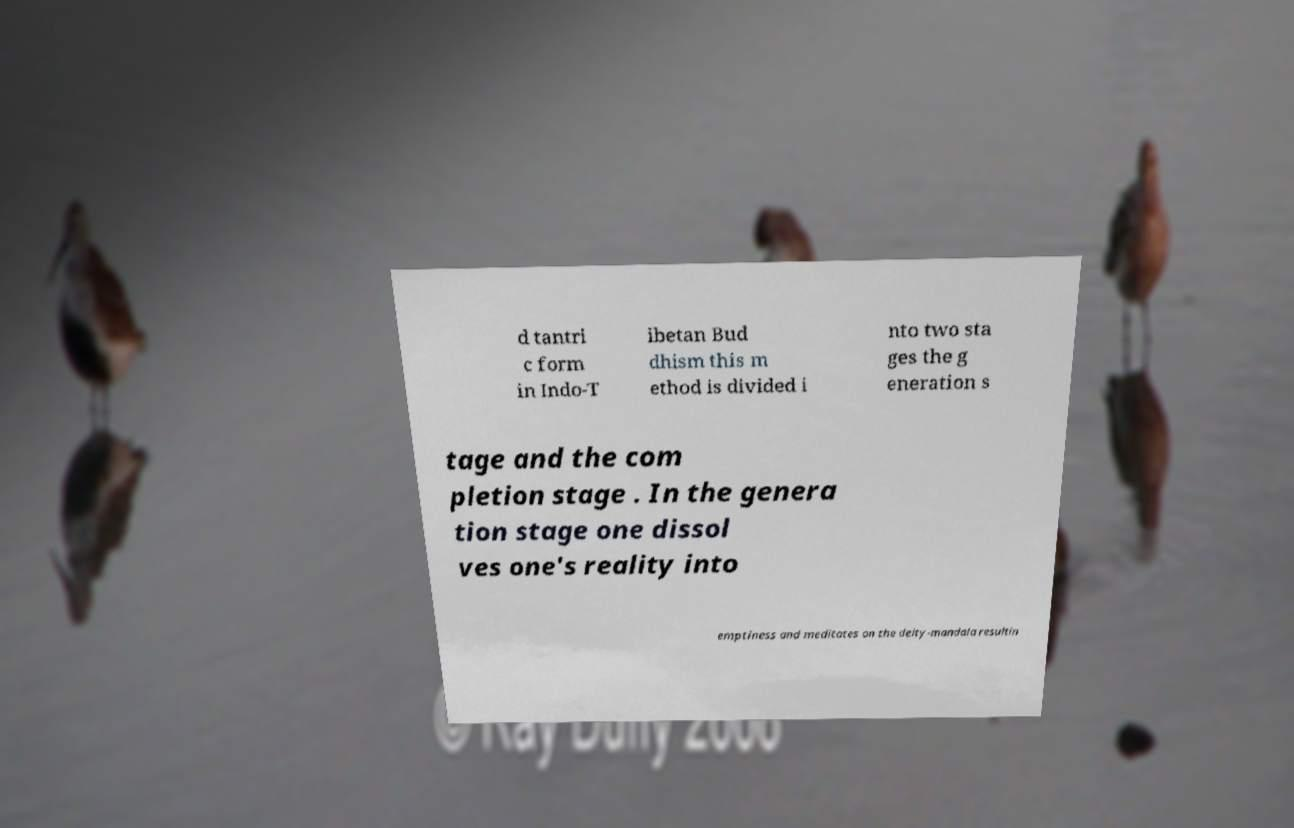I need the written content from this picture converted into text. Can you do that? d tantri c form in Indo-T ibetan Bud dhism this m ethod is divided i nto two sta ges the g eneration s tage and the com pletion stage . In the genera tion stage one dissol ves one's reality into emptiness and meditates on the deity-mandala resultin 